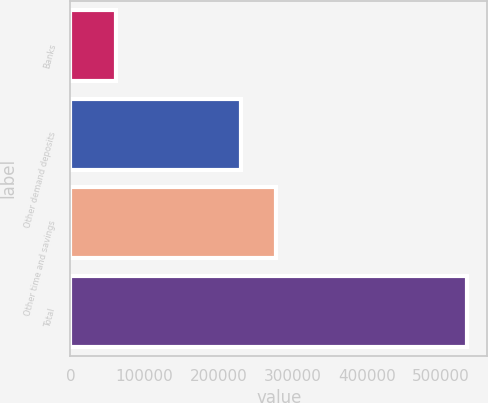<chart> <loc_0><loc_0><loc_500><loc_500><bar_chart><fcel>Banks<fcel>Other demand deposits<fcel>Other time and savings<fcel>Total<nl><fcel>61705<fcel>229880<fcel>277231<fcel>535215<nl></chart> 